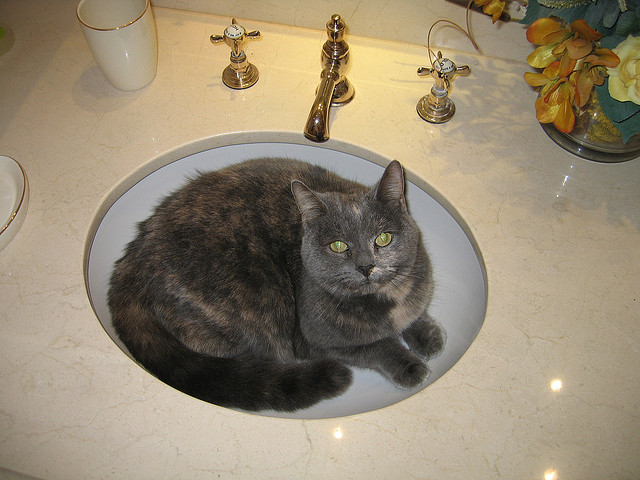Why should this cat be scared?
A. fire
B. noise
C. physical harm
D. water The cat in the image does not appear to be in immediate danger from fire, noise, or physical harm. Water seems the most plausible fear, as it's sitting inside a sink, which is unusual for cats since many of them dislike getting wet. The mere presence or anticipation of water could be unsettling for the cat. 